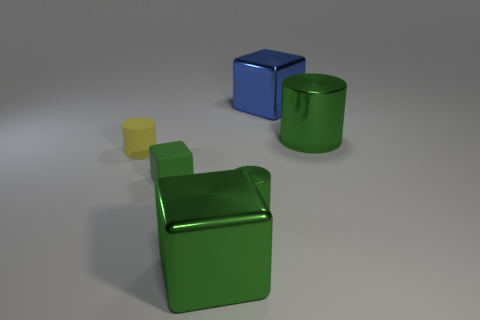Subtract all yellow balls. How many green cylinders are left? 2 Subtract all green cubes. How many cubes are left? 1 Add 3 yellow rubber cylinders. How many objects exist? 9 Subtract 0 green spheres. How many objects are left? 6 Subtract all cyan cubes. Subtract all brown cylinders. How many cubes are left? 3 Subtract all cylinders. Subtract all large gray metal spheres. How many objects are left? 3 Add 4 cylinders. How many cylinders are left? 7 Add 4 large green cubes. How many large green cubes exist? 5 